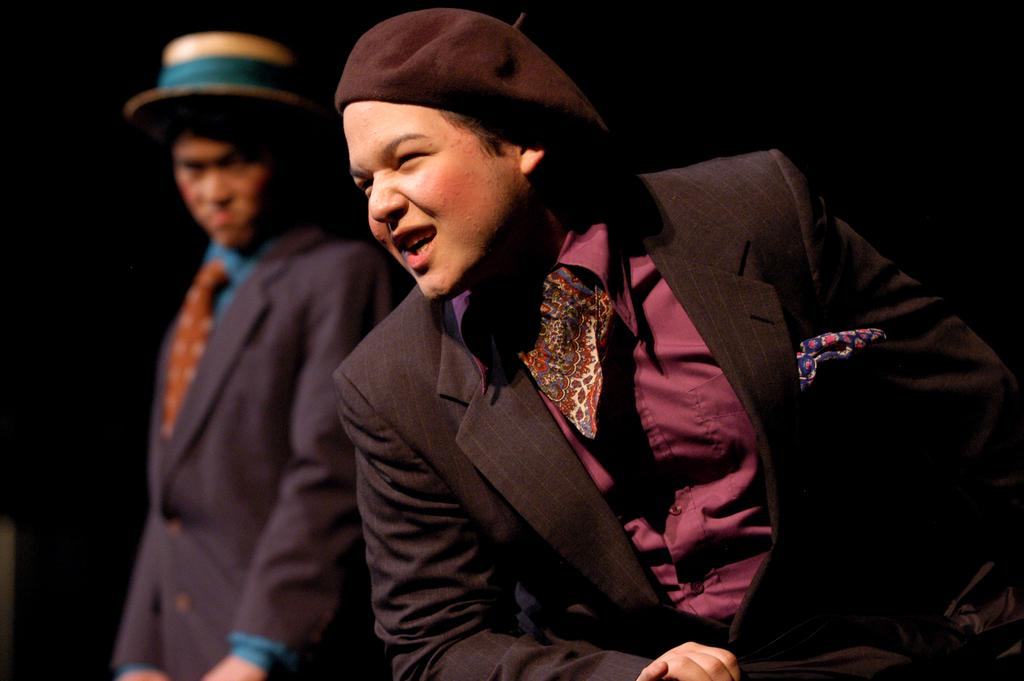How many people are in the image? There are two people in the image. What are the people wearing? Both people are wearing suits. Can you describe the headwear of each person? One person is wearing a cap, and the other person is wearing a hat. What is the facial expression of one of the people? One person is smiling. In which direction is the smiling person looking? The person who is smiling is looking to the left side. What type of fight can be seen taking place between the two people in the image? There is no fight taking place between the two people in the image; they are both wearing suits and appear to be engaged in a different activity or conversation. Can you tell me how many pails are visible in the image? There are no pails present in the image. 